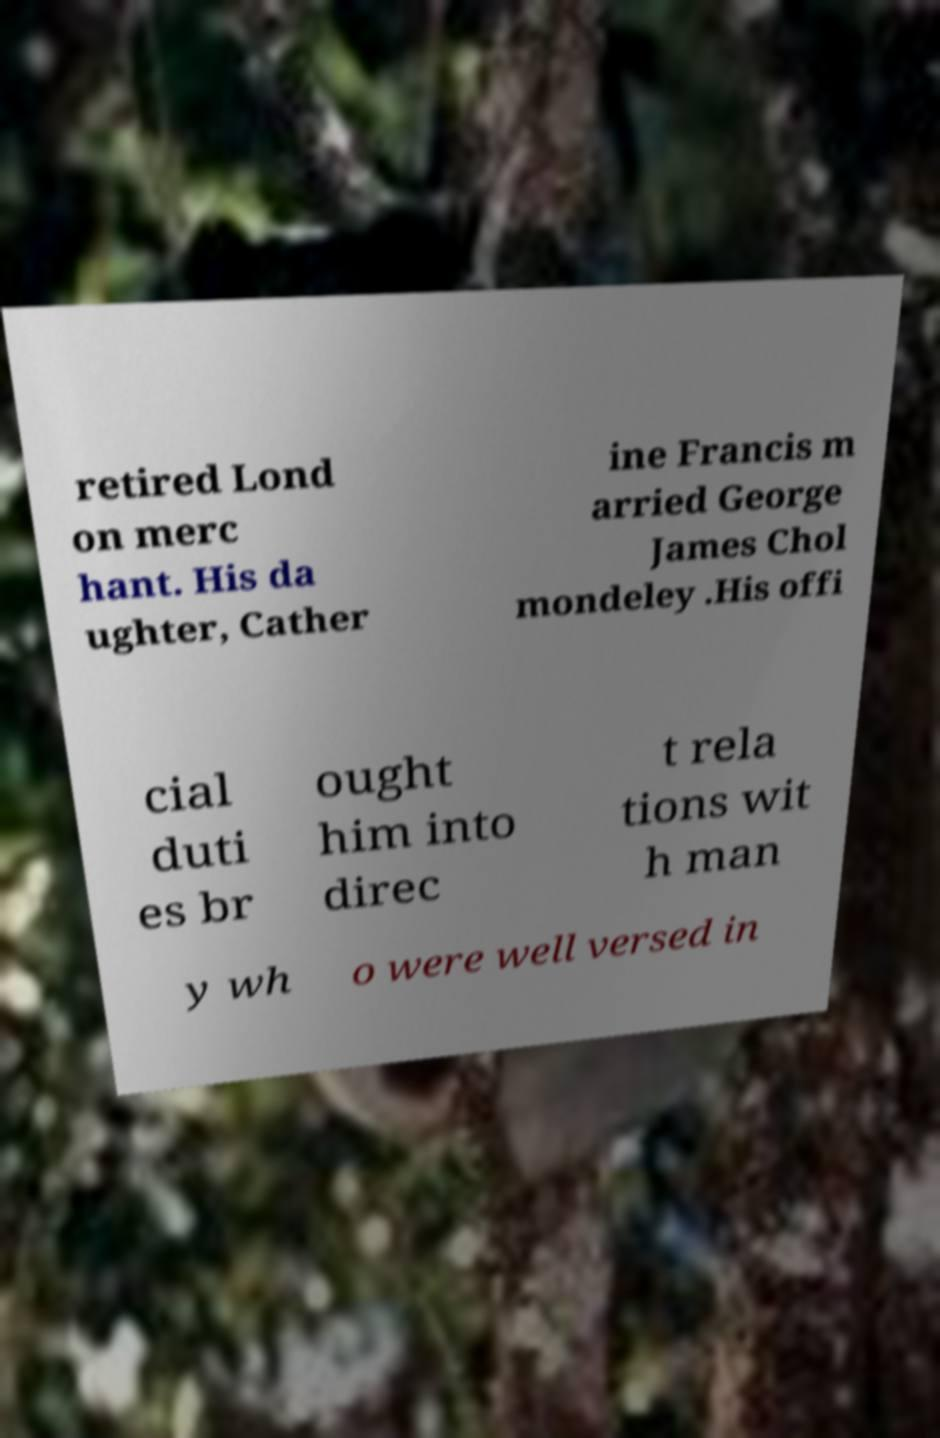What messages or text are displayed in this image? I need them in a readable, typed format. retired Lond on merc hant. His da ughter, Cather ine Francis m arried George James Chol mondeley .His offi cial duti es br ought him into direc t rela tions wit h man y wh o were well versed in 